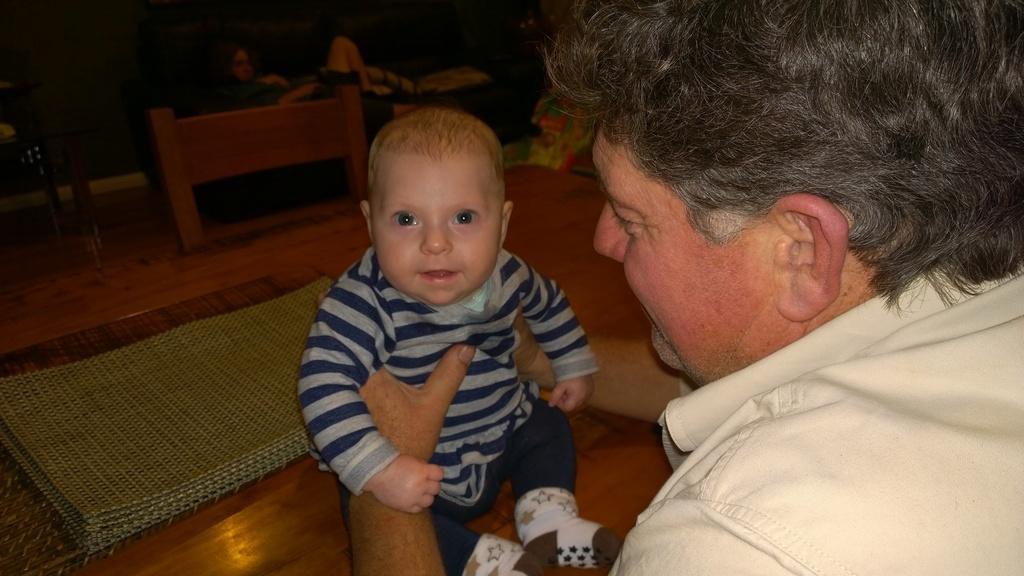Please provide a concise description of this image. A man is holding a baby. And the baby is sitting on a table. On the table there are mats. Beside the table there is a chair. 